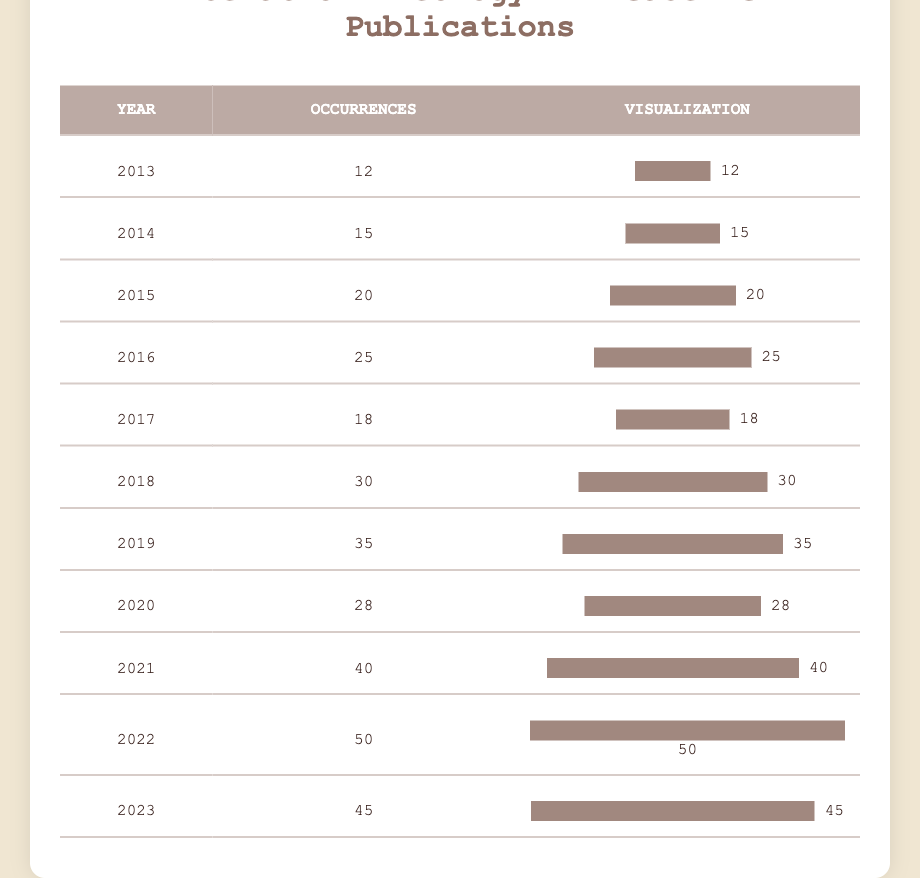What was the highest number of occurrences of liberation theology in a single year? Looking at the table, the highest number of occurrences recorded is in the year 2022 with 50 occurrences.
Answer: 50 In which year did the occurrences of liberation theology first exceed 25? By examining the table, the year 2016 has 25 occurrences, and then in 2017, the occurrences dropped to 18. The next year after 2016 where occurrences exceed 25 is 2018 with 30 occurrences.
Answer: 2018 What is the total number of occurrences from 2013 to 2020? We can calculate this by adding the occurrences from each year: 12 + 15 + 20 + 25 + 18 + 30 + 35 + 28 = 183.
Answer: 183 Did the number of occurrences in 2021 increase compared to the previous year? Comparing the occurrences of 2021 (40) with 2020 (28), we see that the number in 2021 increased.
Answer: Yes What is the average number of occurrences of liberation theology over the entire decade? To find the average, we sum the occurrences from all years (12 + 15 + 20 + 25 + 18 + 30 + 35 + 28 + 40 + 50 + 45 =  378) and divide by the number of years (11), resulting in an average of 378/11 ≈ 34.36.
Answer: Approximately 34.36 Which year had the least occurrences of liberation theology? Looking at the table, the year 2013 had the least occurrences with a total of 12.
Answer: 2013 What was the difference in occurrences of liberation theology between the years 2018 and 2022? The occurrences in 2018 were 30 and in 2022 were 50. Therefore, the difference is 50 - 30 = 20.
Answer: 20 In which year was there a noticeable drop in occurrences after a previous increase? In 2017, there was a drop from 30 occurrences in 2018 to 18 occurrences, showing a noticeable decline after the previous increase in 2016 (25).
Answer: 2017 How many years had occurrences of liberation theology greater than or equal to 40? Reviewing the table, there are four years where the occurrences were at least 40: 2021 (40), 2022 (50), and 2023 (45).
Answer: 3 